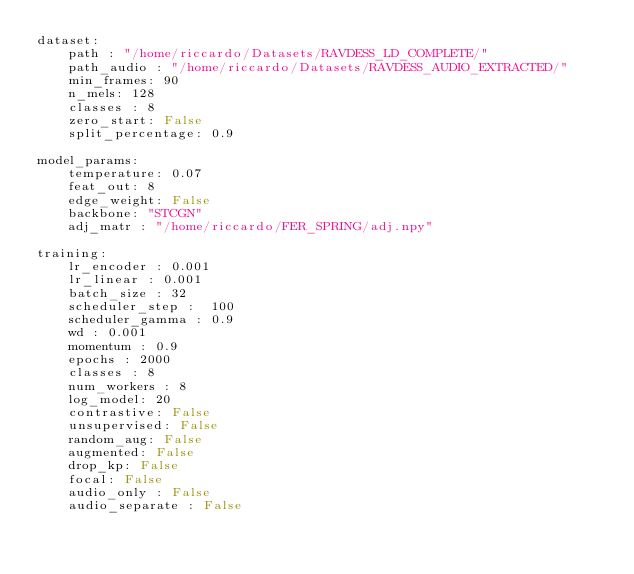Convert code to text. <code><loc_0><loc_0><loc_500><loc_500><_YAML_>dataset:
    path : "/home/riccardo/Datasets/RAVDESS_LD_COMPLETE/"
    path_audio : "/home/riccardo/Datasets/RAVDESS_AUDIO_EXTRACTED/"
    min_frames: 90
    n_mels: 128
    classes : 8
    zero_start: False
    split_percentage: 0.9

model_params:
    temperature: 0.07
    feat_out: 8
    edge_weight: False
    backbone: "STCGN"
    adj_matr : "/home/riccardo/FER_SPRING/adj.npy"

training:
    lr_encoder : 0.001
    lr_linear : 0.001
    batch_size : 32    
    scheduler_step :  100
    scheduler_gamma : 0.9    
    wd : 0.001
    momentum : 0.9
    epochs : 2000
    classes : 8
    num_workers : 8
    log_model: 20
    contrastive: False
    unsupervised: False
    random_aug: False
    augmented: False
    drop_kp: False
    focal: False 
    audio_only : False
    audio_separate : False
</code> 